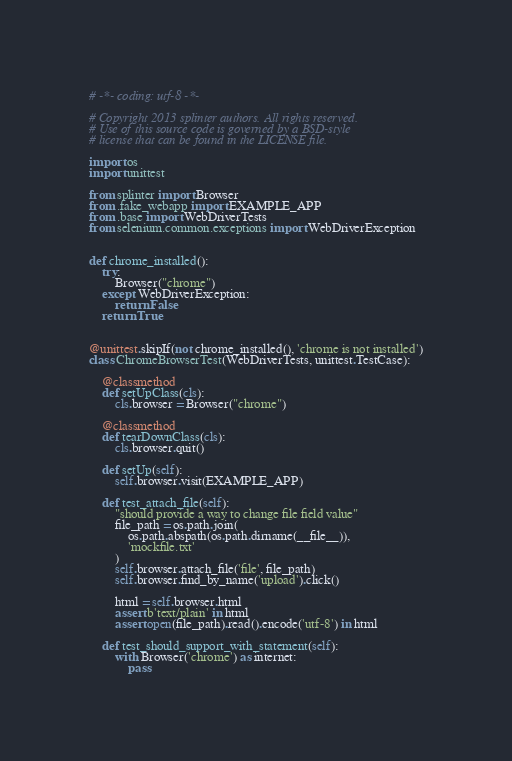<code> <loc_0><loc_0><loc_500><loc_500><_Python_># -*- coding: utf-8 -*-

# Copyright 2013 splinter authors. All rights reserved.
# Use of this source code is governed by a BSD-style
# license that can be found in the LICENSE file.

import os
import unittest

from splinter import Browser
from .fake_webapp import EXAMPLE_APP
from .base import WebDriverTests
from selenium.common.exceptions import WebDriverException


def chrome_installed():
    try:
        Browser("chrome")
    except WebDriverException:
        return False
    return True


@unittest.skipIf(not chrome_installed(), 'chrome is not installed')
class ChromeBrowserTest(WebDriverTests, unittest.TestCase):

    @classmethod
    def setUpClass(cls):
        cls.browser = Browser("chrome")

    @classmethod
    def tearDownClass(cls):
        cls.browser.quit()

    def setUp(self):
        self.browser.visit(EXAMPLE_APP)

    def test_attach_file(self):
        "should provide a way to change file field value"
        file_path = os.path.join(
            os.path.abspath(os.path.dirname(__file__)),
            'mockfile.txt'
        )
        self.browser.attach_file('file', file_path)
        self.browser.find_by_name('upload').click()

        html = self.browser.html
        assert b'text/plain' in html
        assert open(file_path).read().encode('utf-8') in html

    def test_should_support_with_statement(self):
        with Browser('chrome') as internet:
            pass
</code> 